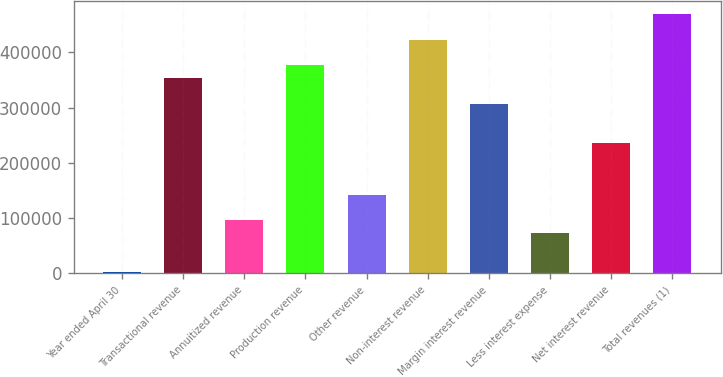<chart> <loc_0><loc_0><loc_500><loc_500><bar_chart><fcel>Year ended April 30<fcel>Transactional revenue<fcel>Annuitized revenue<fcel>Production revenue<fcel>Other revenue<fcel>Non-interest revenue<fcel>Margin interest revenue<fcel>Less interest expense<fcel>Net interest revenue<fcel>Total revenues (1)<nl><fcel>2002<fcel>352910<fcel>95577.6<fcel>376304<fcel>142365<fcel>423092<fcel>306123<fcel>72183.7<fcel>235941<fcel>469880<nl></chart> 